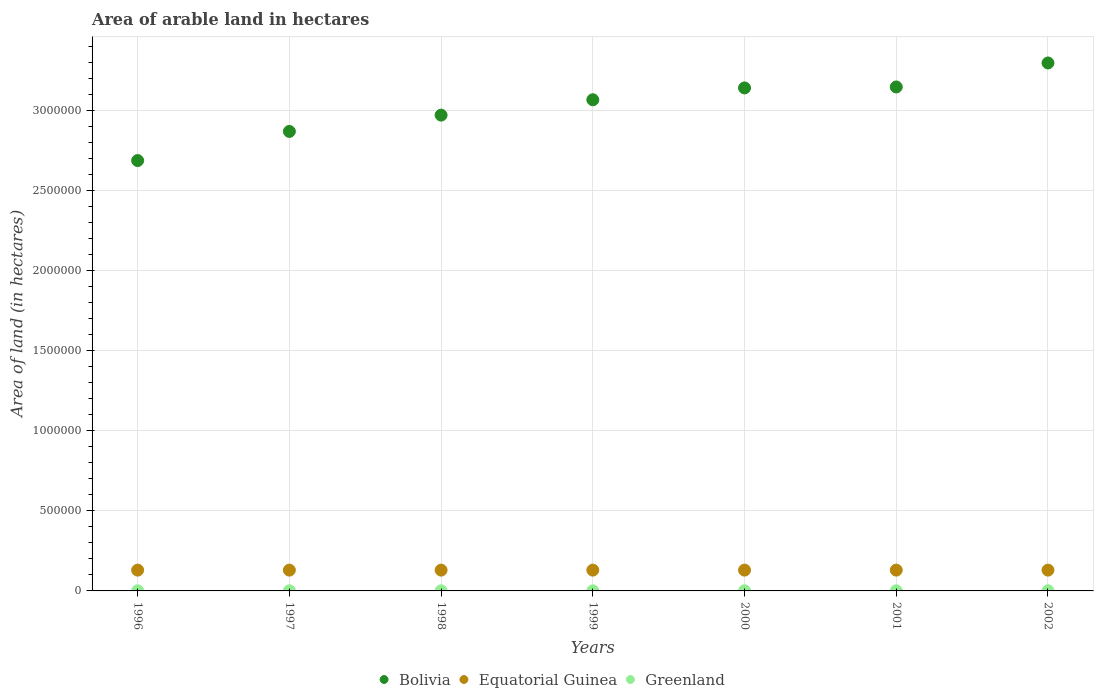How many different coloured dotlines are there?
Make the answer very short. 3. What is the total arable land in Greenland in 1997?
Your response must be concise. 700. Across all years, what is the maximum total arable land in Greenland?
Provide a succinct answer. 900. Across all years, what is the minimum total arable land in Greenland?
Offer a terse response. 700. In which year was the total arable land in Bolivia minimum?
Your answer should be very brief. 1996. What is the total total arable land in Greenland in the graph?
Make the answer very short. 5300. What is the difference between the total arable land in Bolivia in 1996 and that in 2000?
Give a very brief answer. -4.54e+05. What is the difference between the total arable land in Bolivia in 1998 and the total arable land in Greenland in 1996?
Provide a short and direct response. 2.97e+06. What is the average total arable land in Bolivia per year?
Your answer should be compact. 3.03e+06. In the year 2000, what is the difference between the total arable land in Equatorial Guinea and total arable land in Bolivia?
Provide a short and direct response. -3.01e+06. Is the sum of the total arable land in Equatorial Guinea in 1996 and 2000 greater than the maximum total arable land in Bolivia across all years?
Provide a short and direct response. No. Does the total arable land in Bolivia monotonically increase over the years?
Provide a succinct answer. Yes. How many years are there in the graph?
Offer a very short reply. 7. Are the values on the major ticks of Y-axis written in scientific E-notation?
Offer a terse response. No. Does the graph contain any zero values?
Make the answer very short. No. Where does the legend appear in the graph?
Give a very brief answer. Bottom center. What is the title of the graph?
Offer a very short reply. Area of arable land in hectares. What is the label or title of the Y-axis?
Offer a very short reply. Area of land (in hectares). What is the Area of land (in hectares) of Bolivia in 1996?
Provide a succinct answer. 2.69e+06. What is the Area of land (in hectares) in Equatorial Guinea in 1996?
Provide a succinct answer. 1.30e+05. What is the Area of land (in hectares) in Greenland in 1996?
Your answer should be compact. 700. What is the Area of land (in hectares) in Bolivia in 1997?
Your response must be concise. 2.87e+06. What is the Area of land (in hectares) of Greenland in 1997?
Keep it short and to the point. 700. What is the Area of land (in hectares) in Bolivia in 1998?
Your response must be concise. 2.97e+06. What is the Area of land (in hectares) in Greenland in 1998?
Your response must be concise. 700. What is the Area of land (in hectares) of Bolivia in 1999?
Offer a very short reply. 3.07e+06. What is the Area of land (in hectares) of Greenland in 1999?
Provide a succinct answer. 700. What is the Area of land (in hectares) of Bolivia in 2000?
Offer a very short reply. 3.14e+06. What is the Area of land (in hectares) of Equatorial Guinea in 2000?
Your response must be concise. 1.30e+05. What is the Area of land (in hectares) in Greenland in 2000?
Offer a very short reply. 800. What is the Area of land (in hectares) of Bolivia in 2001?
Provide a short and direct response. 3.15e+06. What is the Area of land (in hectares) in Equatorial Guinea in 2001?
Your response must be concise. 1.30e+05. What is the Area of land (in hectares) of Greenland in 2001?
Your answer should be very brief. 800. What is the Area of land (in hectares) of Bolivia in 2002?
Provide a succinct answer. 3.30e+06. What is the Area of land (in hectares) in Greenland in 2002?
Make the answer very short. 900. Across all years, what is the maximum Area of land (in hectares) of Bolivia?
Keep it short and to the point. 3.30e+06. Across all years, what is the maximum Area of land (in hectares) of Equatorial Guinea?
Your response must be concise. 1.30e+05. Across all years, what is the maximum Area of land (in hectares) of Greenland?
Your response must be concise. 900. Across all years, what is the minimum Area of land (in hectares) in Bolivia?
Provide a succinct answer. 2.69e+06. Across all years, what is the minimum Area of land (in hectares) of Equatorial Guinea?
Offer a very short reply. 1.30e+05. Across all years, what is the minimum Area of land (in hectares) in Greenland?
Your response must be concise. 700. What is the total Area of land (in hectares) of Bolivia in the graph?
Give a very brief answer. 2.12e+07. What is the total Area of land (in hectares) in Equatorial Guinea in the graph?
Give a very brief answer. 9.10e+05. What is the total Area of land (in hectares) of Greenland in the graph?
Give a very brief answer. 5300. What is the difference between the Area of land (in hectares) in Bolivia in 1996 and that in 1997?
Make the answer very short. -1.82e+05. What is the difference between the Area of land (in hectares) in Greenland in 1996 and that in 1997?
Ensure brevity in your answer.  0. What is the difference between the Area of land (in hectares) of Bolivia in 1996 and that in 1998?
Provide a short and direct response. -2.84e+05. What is the difference between the Area of land (in hectares) of Greenland in 1996 and that in 1998?
Keep it short and to the point. 0. What is the difference between the Area of land (in hectares) in Bolivia in 1996 and that in 1999?
Offer a terse response. -3.80e+05. What is the difference between the Area of land (in hectares) of Equatorial Guinea in 1996 and that in 1999?
Provide a succinct answer. 0. What is the difference between the Area of land (in hectares) in Bolivia in 1996 and that in 2000?
Give a very brief answer. -4.54e+05. What is the difference between the Area of land (in hectares) of Greenland in 1996 and that in 2000?
Your response must be concise. -100. What is the difference between the Area of land (in hectares) of Bolivia in 1996 and that in 2001?
Your answer should be compact. -4.60e+05. What is the difference between the Area of land (in hectares) of Equatorial Guinea in 1996 and that in 2001?
Your answer should be very brief. 0. What is the difference between the Area of land (in hectares) of Greenland in 1996 and that in 2001?
Your response must be concise. -100. What is the difference between the Area of land (in hectares) of Bolivia in 1996 and that in 2002?
Offer a terse response. -6.10e+05. What is the difference between the Area of land (in hectares) of Equatorial Guinea in 1996 and that in 2002?
Your answer should be compact. 0. What is the difference between the Area of land (in hectares) of Greenland in 1996 and that in 2002?
Provide a succinct answer. -200. What is the difference between the Area of land (in hectares) in Bolivia in 1997 and that in 1998?
Give a very brief answer. -1.02e+05. What is the difference between the Area of land (in hectares) of Bolivia in 1997 and that in 1999?
Offer a terse response. -1.98e+05. What is the difference between the Area of land (in hectares) in Bolivia in 1997 and that in 2000?
Provide a short and direct response. -2.72e+05. What is the difference between the Area of land (in hectares) in Greenland in 1997 and that in 2000?
Ensure brevity in your answer.  -100. What is the difference between the Area of land (in hectares) in Bolivia in 1997 and that in 2001?
Offer a very short reply. -2.78e+05. What is the difference between the Area of land (in hectares) of Greenland in 1997 and that in 2001?
Provide a short and direct response. -100. What is the difference between the Area of land (in hectares) of Bolivia in 1997 and that in 2002?
Provide a short and direct response. -4.28e+05. What is the difference between the Area of land (in hectares) in Greenland in 1997 and that in 2002?
Offer a very short reply. -200. What is the difference between the Area of land (in hectares) in Bolivia in 1998 and that in 1999?
Your answer should be very brief. -9.60e+04. What is the difference between the Area of land (in hectares) in Equatorial Guinea in 1998 and that in 1999?
Your answer should be compact. 0. What is the difference between the Area of land (in hectares) of Bolivia in 1998 and that in 2000?
Your answer should be very brief. -1.70e+05. What is the difference between the Area of land (in hectares) in Greenland in 1998 and that in 2000?
Provide a short and direct response. -100. What is the difference between the Area of land (in hectares) in Bolivia in 1998 and that in 2001?
Keep it short and to the point. -1.76e+05. What is the difference between the Area of land (in hectares) of Greenland in 1998 and that in 2001?
Offer a very short reply. -100. What is the difference between the Area of land (in hectares) in Bolivia in 1998 and that in 2002?
Give a very brief answer. -3.26e+05. What is the difference between the Area of land (in hectares) of Equatorial Guinea in 1998 and that in 2002?
Provide a short and direct response. 0. What is the difference between the Area of land (in hectares) in Greenland in 1998 and that in 2002?
Offer a terse response. -200. What is the difference between the Area of land (in hectares) in Bolivia in 1999 and that in 2000?
Keep it short and to the point. -7.40e+04. What is the difference between the Area of land (in hectares) of Greenland in 1999 and that in 2000?
Ensure brevity in your answer.  -100. What is the difference between the Area of land (in hectares) of Bolivia in 1999 and that in 2001?
Make the answer very short. -8.00e+04. What is the difference between the Area of land (in hectares) in Greenland in 1999 and that in 2001?
Provide a succinct answer. -100. What is the difference between the Area of land (in hectares) in Greenland in 1999 and that in 2002?
Give a very brief answer. -200. What is the difference between the Area of land (in hectares) in Bolivia in 2000 and that in 2001?
Make the answer very short. -6000. What is the difference between the Area of land (in hectares) of Greenland in 2000 and that in 2001?
Your answer should be very brief. 0. What is the difference between the Area of land (in hectares) in Bolivia in 2000 and that in 2002?
Provide a short and direct response. -1.56e+05. What is the difference between the Area of land (in hectares) in Greenland in 2000 and that in 2002?
Provide a succinct answer. -100. What is the difference between the Area of land (in hectares) of Bolivia in 2001 and that in 2002?
Make the answer very short. -1.50e+05. What is the difference between the Area of land (in hectares) in Greenland in 2001 and that in 2002?
Your response must be concise. -100. What is the difference between the Area of land (in hectares) in Bolivia in 1996 and the Area of land (in hectares) in Equatorial Guinea in 1997?
Offer a terse response. 2.56e+06. What is the difference between the Area of land (in hectares) in Bolivia in 1996 and the Area of land (in hectares) in Greenland in 1997?
Your answer should be very brief. 2.69e+06. What is the difference between the Area of land (in hectares) of Equatorial Guinea in 1996 and the Area of land (in hectares) of Greenland in 1997?
Give a very brief answer. 1.29e+05. What is the difference between the Area of land (in hectares) of Bolivia in 1996 and the Area of land (in hectares) of Equatorial Guinea in 1998?
Offer a terse response. 2.56e+06. What is the difference between the Area of land (in hectares) in Bolivia in 1996 and the Area of land (in hectares) in Greenland in 1998?
Your answer should be compact. 2.69e+06. What is the difference between the Area of land (in hectares) of Equatorial Guinea in 1996 and the Area of land (in hectares) of Greenland in 1998?
Offer a terse response. 1.29e+05. What is the difference between the Area of land (in hectares) in Bolivia in 1996 and the Area of land (in hectares) in Equatorial Guinea in 1999?
Keep it short and to the point. 2.56e+06. What is the difference between the Area of land (in hectares) of Bolivia in 1996 and the Area of land (in hectares) of Greenland in 1999?
Offer a very short reply. 2.69e+06. What is the difference between the Area of land (in hectares) of Equatorial Guinea in 1996 and the Area of land (in hectares) of Greenland in 1999?
Provide a short and direct response. 1.29e+05. What is the difference between the Area of land (in hectares) of Bolivia in 1996 and the Area of land (in hectares) of Equatorial Guinea in 2000?
Offer a terse response. 2.56e+06. What is the difference between the Area of land (in hectares) in Bolivia in 1996 and the Area of land (in hectares) in Greenland in 2000?
Keep it short and to the point. 2.69e+06. What is the difference between the Area of land (in hectares) in Equatorial Guinea in 1996 and the Area of land (in hectares) in Greenland in 2000?
Ensure brevity in your answer.  1.29e+05. What is the difference between the Area of land (in hectares) of Bolivia in 1996 and the Area of land (in hectares) of Equatorial Guinea in 2001?
Provide a succinct answer. 2.56e+06. What is the difference between the Area of land (in hectares) of Bolivia in 1996 and the Area of land (in hectares) of Greenland in 2001?
Provide a succinct answer. 2.69e+06. What is the difference between the Area of land (in hectares) of Equatorial Guinea in 1996 and the Area of land (in hectares) of Greenland in 2001?
Provide a short and direct response. 1.29e+05. What is the difference between the Area of land (in hectares) in Bolivia in 1996 and the Area of land (in hectares) in Equatorial Guinea in 2002?
Give a very brief answer. 2.56e+06. What is the difference between the Area of land (in hectares) in Bolivia in 1996 and the Area of land (in hectares) in Greenland in 2002?
Your answer should be compact. 2.69e+06. What is the difference between the Area of land (in hectares) in Equatorial Guinea in 1996 and the Area of land (in hectares) in Greenland in 2002?
Provide a succinct answer. 1.29e+05. What is the difference between the Area of land (in hectares) of Bolivia in 1997 and the Area of land (in hectares) of Equatorial Guinea in 1998?
Give a very brief answer. 2.74e+06. What is the difference between the Area of land (in hectares) of Bolivia in 1997 and the Area of land (in hectares) of Greenland in 1998?
Keep it short and to the point. 2.87e+06. What is the difference between the Area of land (in hectares) in Equatorial Guinea in 1997 and the Area of land (in hectares) in Greenland in 1998?
Your answer should be compact. 1.29e+05. What is the difference between the Area of land (in hectares) of Bolivia in 1997 and the Area of land (in hectares) of Equatorial Guinea in 1999?
Give a very brief answer. 2.74e+06. What is the difference between the Area of land (in hectares) in Bolivia in 1997 and the Area of land (in hectares) in Greenland in 1999?
Ensure brevity in your answer.  2.87e+06. What is the difference between the Area of land (in hectares) in Equatorial Guinea in 1997 and the Area of land (in hectares) in Greenland in 1999?
Offer a very short reply. 1.29e+05. What is the difference between the Area of land (in hectares) of Bolivia in 1997 and the Area of land (in hectares) of Equatorial Guinea in 2000?
Provide a succinct answer. 2.74e+06. What is the difference between the Area of land (in hectares) in Bolivia in 1997 and the Area of land (in hectares) in Greenland in 2000?
Your answer should be compact. 2.87e+06. What is the difference between the Area of land (in hectares) in Equatorial Guinea in 1997 and the Area of land (in hectares) in Greenland in 2000?
Your response must be concise. 1.29e+05. What is the difference between the Area of land (in hectares) of Bolivia in 1997 and the Area of land (in hectares) of Equatorial Guinea in 2001?
Make the answer very short. 2.74e+06. What is the difference between the Area of land (in hectares) of Bolivia in 1997 and the Area of land (in hectares) of Greenland in 2001?
Offer a very short reply. 2.87e+06. What is the difference between the Area of land (in hectares) in Equatorial Guinea in 1997 and the Area of land (in hectares) in Greenland in 2001?
Your answer should be compact. 1.29e+05. What is the difference between the Area of land (in hectares) of Bolivia in 1997 and the Area of land (in hectares) of Equatorial Guinea in 2002?
Provide a short and direct response. 2.74e+06. What is the difference between the Area of land (in hectares) in Bolivia in 1997 and the Area of land (in hectares) in Greenland in 2002?
Your response must be concise. 2.87e+06. What is the difference between the Area of land (in hectares) of Equatorial Guinea in 1997 and the Area of land (in hectares) of Greenland in 2002?
Offer a very short reply. 1.29e+05. What is the difference between the Area of land (in hectares) in Bolivia in 1998 and the Area of land (in hectares) in Equatorial Guinea in 1999?
Your answer should be very brief. 2.84e+06. What is the difference between the Area of land (in hectares) in Bolivia in 1998 and the Area of land (in hectares) in Greenland in 1999?
Keep it short and to the point. 2.97e+06. What is the difference between the Area of land (in hectares) of Equatorial Guinea in 1998 and the Area of land (in hectares) of Greenland in 1999?
Your answer should be compact. 1.29e+05. What is the difference between the Area of land (in hectares) in Bolivia in 1998 and the Area of land (in hectares) in Equatorial Guinea in 2000?
Offer a very short reply. 2.84e+06. What is the difference between the Area of land (in hectares) in Bolivia in 1998 and the Area of land (in hectares) in Greenland in 2000?
Offer a terse response. 2.97e+06. What is the difference between the Area of land (in hectares) in Equatorial Guinea in 1998 and the Area of land (in hectares) in Greenland in 2000?
Ensure brevity in your answer.  1.29e+05. What is the difference between the Area of land (in hectares) in Bolivia in 1998 and the Area of land (in hectares) in Equatorial Guinea in 2001?
Your response must be concise. 2.84e+06. What is the difference between the Area of land (in hectares) of Bolivia in 1998 and the Area of land (in hectares) of Greenland in 2001?
Your answer should be very brief. 2.97e+06. What is the difference between the Area of land (in hectares) of Equatorial Guinea in 1998 and the Area of land (in hectares) of Greenland in 2001?
Provide a short and direct response. 1.29e+05. What is the difference between the Area of land (in hectares) in Bolivia in 1998 and the Area of land (in hectares) in Equatorial Guinea in 2002?
Provide a short and direct response. 2.84e+06. What is the difference between the Area of land (in hectares) in Bolivia in 1998 and the Area of land (in hectares) in Greenland in 2002?
Provide a succinct answer. 2.97e+06. What is the difference between the Area of land (in hectares) in Equatorial Guinea in 1998 and the Area of land (in hectares) in Greenland in 2002?
Your answer should be very brief. 1.29e+05. What is the difference between the Area of land (in hectares) of Bolivia in 1999 and the Area of land (in hectares) of Equatorial Guinea in 2000?
Make the answer very short. 2.94e+06. What is the difference between the Area of land (in hectares) of Bolivia in 1999 and the Area of land (in hectares) of Greenland in 2000?
Your answer should be very brief. 3.07e+06. What is the difference between the Area of land (in hectares) in Equatorial Guinea in 1999 and the Area of land (in hectares) in Greenland in 2000?
Your answer should be compact. 1.29e+05. What is the difference between the Area of land (in hectares) in Bolivia in 1999 and the Area of land (in hectares) in Equatorial Guinea in 2001?
Make the answer very short. 2.94e+06. What is the difference between the Area of land (in hectares) of Bolivia in 1999 and the Area of land (in hectares) of Greenland in 2001?
Your answer should be compact. 3.07e+06. What is the difference between the Area of land (in hectares) of Equatorial Guinea in 1999 and the Area of land (in hectares) of Greenland in 2001?
Provide a short and direct response. 1.29e+05. What is the difference between the Area of land (in hectares) in Bolivia in 1999 and the Area of land (in hectares) in Equatorial Guinea in 2002?
Your answer should be very brief. 2.94e+06. What is the difference between the Area of land (in hectares) of Bolivia in 1999 and the Area of land (in hectares) of Greenland in 2002?
Ensure brevity in your answer.  3.07e+06. What is the difference between the Area of land (in hectares) of Equatorial Guinea in 1999 and the Area of land (in hectares) of Greenland in 2002?
Offer a terse response. 1.29e+05. What is the difference between the Area of land (in hectares) in Bolivia in 2000 and the Area of land (in hectares) in Equatorial Guinea in 2001?
Provide a short and direct response. 3.01e+06. What is the difference between the Area of land (in hectares) of Bolivia in 2000 and the Area of land (in hectares) of Greenland in 2001?
Give a very brief answer. 3.14e+06. What is the difference between the Area of land (in hectares) in Equatorial Guinea in 2000 and the Area of land (in hectares) in Greenland in 2001?
Offer a terse response. 1.29e+05. What is the difference between the Area of land (in hectares) in Bolivia in 2000 and the Area of land (in hectares) in Equatorial Guinea in 2002?
Your response must be concise. 3.01e+06. What is the difference between the Area of land (in hectares) in Bolivia in 2000 and the Area of land (in hectares) in Greenland in 2002?
Your answer should be very brief. 3.14e+06. What is the difference between the Area of land (in hectares) of Equatorial Guinea in 2000 and the Area of land (in hectares) of Greenland in 2002?
Your answer should be compact. 1.29e+05. What is the difference between the Area of land (in hectares) in Bolivia in 2001 and the Area of land (in hectares) in Equatorial Guinea in 2002?
Provide a short and direct response. 3.02e+06. What is the difference between the Area of land (in hectares) of Bolivia in 2001 and the Area of land (in hectares) of Greenland in 2002?
Offer a very short reply. 3.15e+06. What is the difference between the Area of land (in hectares) of Equatorial Guinea in 2001 and the Area of land (in hectares) of Greenland in 2002?
Offer a very short reply. 1.29e+05. What is the average Area of land (in hectares) in Bolivia per year?
Offer a very short reply. 3.03e+06. What is the average Area of land (in hectares) in Equatorial Guinea per year?
Offer a terse response. 1.30e+05. What is the average Area of land (in hectares) in Greenland per year?
Offer a terse response. 757.14. In the year 1996, what is the difference between the Area of land (in hectares) of Bolivia and Area of land (in hectares) of Equatorial Guinea?
Provide a short and direct response. 2.56e+06. In the year 1996, what is the difference between the Area of land (in hectares) of Bolivia and Area of land (in hectares) of Greenland?
Your answer should be very brief. 2.69e+06. In the year 1996, what is the difference between the Area of land (in hectares) in Equatorial Guinea and Area of land (in hectares) in Greenland?
Provide a short and direct response. 1.29e+05. In the year 1997, what is the difference between the Area of land (in hectares) of Bolivia and Area of land (in hectares) of Equatorial Guinea?
Your response must be concise. 2.74e+06. In the year 1997, what is the difference between the Area of land (in hectares) in Bolivia and Area of land (in hectares) in Greenland?
Give a very brief answer. 2.87e+06. In the year 1997, what is the difference between the Area of land (in hectares) of Equatorial Guinea and Area of land (in hectares) of Greenland?
Provide a succinct answer. 1.29e+05. In the year 1998, what is the difference between the Area of land (in hectares) in Bolivia and Area of land (in hectares) in Equatorial Guinea?
Give a very brief answer. 2.84e+06. In the year 1998, what is the difference between the Area of land (in hectares) of Bolivia and Area of land (in hectares) of Greenland?
Keep it short and to the point. 2.97e+06. In the year 1998, what is the difference between the Area of land (in hectares) in Equatorial Guinea and Area of land (in hectares) in Greenland?
Keep it short and to the point. 1.29e+05. In the year 1999, what is the difference between the Area of land (in hectares) in Bolivia and Area of land (in hectares) in Equatorial Guinea?
Keep it short and to the point. 2.94e+06. In the year 1999, what is the difference between the Area of land (in hectares) of Bolivia and Area of land (in hectares) of Greenland?
Offer a terse response. 3.07e+06. In the year 1999, what is the difference between the Area of land (in hectares) in Equatorial Guinea and Area of land (in hectares) in Greenland?
Offer a terse response. 1.29e+05. In the year 2000, what is the difference between the Area of land (in hectares) of Bolivia and Area of land (in hectares) of Equatorial Guinea?
Provide a succinct answer. 3.01e+06. In the year 2000, what is the difference between the Area of land (in hectares) in Bolivia and Area of land (in hectares) in Greenland?
Your answer should be compact. 3.14e+06. In the year 2000, what is the difference between the Area of land (in hectares) in Equatorial Guinea and Area of land (in hectares) in Greenland?
Provide a succinct answer. 1.29e+05. In the year 2001, what is the difference between the Area of land (in hectares) of Bolivia and Area of land (in hectares) of Equatorial Guinea?
Ensure brevity in your answer.  3.02e+06. In the year 2001, what is the difference between the Area of land (in hectares) in Bolivia and Area of land (in hectares) in Greenland?
Ensure brevity in your answer.  3.15e+06. In the year 2001, what is the difference between the Area of land (in hectares) in Equatorial Guinea and Area of land (in hectares) in Greenland?
Keep it short and to the point. 1.29e+05. In the year 2002, what is the difference between the Area of land (in hectares) in Bolivia and Area of land (in hectares) in Equatorial Guinea?
Keep it short and to the point. 3.17e+06. In the year 2002, what is the difference between the Area of land (in hectares) in Bolivia and Area of land (in hectares) in Greenland?
Ensure brevity in your answer.  3.30e+06. In the year 2002, what is the difference between the Area of land (in hectares) of Equatorial Guinea and Area of land (in hectares) of Greenland?
Provide a succinct answer. 1.29e+05. What is the ratio of the Area of land (in hectares) in Bolivia in 1996 to that in 1997?
Provide a short and direct response. 0.94. What is the ratio of the Area of land (in hectares) of Greenland in 1996 to that in 1997?
Keep it short and to the point. 1. What is the ratio of the Area of land (in hectares) of Bolivia in 1996 to that in 1998?
Give a very brief answer. 0.9. What is the ratio of the Area of land (in hectares) in Bolivia in 1996 to that in 1999?
Your answer should be very brief. 0.88. What is the ratio of the Area of land (in hectares) in Bolivia in 1996 to that in 2000?
Offer a terse response. 0.86. What is the ratio of the Area of land (in hectares) of Equatorial Guinea in 1996 to that in 2000?
Keep it short and to the point. 1. What is the ratio of the Area of land (in hectares) in Bolivia in 1996 to that in 2001?
Give a very brief answer. 0.85. What is the ratio of the Area of land (in hectares) in Bolivia in 1996 to that in 2002?
Your answer should be very brief. 0.82. What is the ratio of the Area of land (in hectares) in Bolivia in 1997 to that in 1998?
Provide a short and direct response. 0.97. What is the ratio of the Area of land (in hectares) of Bolivia in 1997 to that in 1999?
Offer a very short reply. 0.94. What is the ratio of the Area of land (in hectares) of Bolivia in 1997 to that in 2000?
Your answer should be compact. 0.91. What is the ratio of the Area of land (in hectares) of Bolivia in 1997 to that in 2001?
Your response must be concise. 0.91. What is the ratio of the Area of land (in hectares) in Equatorial Guinea in 1997 to that in 2001?
Offer a very short reply. 1. What is the ratio of the Area of land (in hectares) in Greenland in 1997 to that in 2001?
Make the answer very short. 0.88. What is the ratio of the Area of land (in hectares) in Bolivia in 1997 to that in 2002?
Provide a succinct answer. 0.87. What is the ratio of the Area of land (in hectares) of Equatorial Guinea in 1997 to that in 2002?
Offer a very short reply. 1. What is the ratio of the Area of land (in hectares) in Greenland in 1997 to that in 2002?
Ensure brevity in your answer.  0.78. What is the ratio of the Area of land (in hectares) of Bolivia in 1998 to that in 1999?
Your answer should be very brief. 0.97. What is the ratio of the Area of land (in hectares) in Equatorial Guinea in 1998 to that in 1999?
Provide a short and direct response. 1. What is the ratio of the Area of land (in hectares) of Bolivia in 1998 to that in 2000?
Your answer should be compact. 0.95. What is the ratio of the Area of land (in hectares) of Greenland in 1998 to that in 2000?
Offer a very short reply. 0.88. What is the ratio of the Area of land (in hectares) of Bolivia in 1998 to that in 2001?
Offer a very short reply. 0.94. What is the ratio of the Area of land (in hectares) in Greenland in 1998 to that in 2001?
Your response must be concise. 0.88. What is the ratio of the Area of land (in hectares) in Bolivia in 1998 to that in 2002?
Your answer should be compact. 0.9. What is the ratio of the Area of land (in hectares) in Equatorial Guinea in 1998 to that in 2002?
Keep it short and to the point. 1. What is the ratio of the Area of land (in hectares) in Bolivia in 1999 to that in 2000?
Offer a very short reply. 0.98. What is the ratio of the Area of land (in hectares) in Greenland in 1999 to that in 2000?
Your response must be concise. 0.88. What is the ratio of the Area of land (in hectares) of Bolivia in 1999 to that in 2001?
Give a very brief answer. 0.97. What is the ratio of the Area of land (in hectares) of Equatorial Guinea in 1999 to that in 2001?
Provide a short and direct response. 1. What is the ratio of the Area of land (in hectares) in Greenland in 1999 to that in 2001?
Ensure brevity in your answer.  0.88. What is the ratio of the Area of land (in hectares) of Bolivia in 1999 to that in 2002?
Provide a succinct answer. 0.93. What is the ratio of the Area of land (in hectares) of Equatorial Guinea in 1999 to that in 2002?
Keep it short and to the point. 1. What is the ratio of the Area of land (in hectares) of Greenland in 1999 to that in 2002?
Offer a very short reply. 0.78. What is the ratio of the Area of land (in hectares) in Equatorial Guinea in 2000 to that in 2001?
Your answer should be very brief. 1. What is the ratio of the Area of land (in hectares) in Greenland in 2000 to that in 2001?
Give a very brief answer. 1. What is the ratio of the Area of land (in hectares) in Bolivia in 2000 to that in 2002?
Your answer should be very brief. 0.95. What is the ratio of the Area of land (in hectares) in Greenland in 2000 to that in 2002?
Offer a very short reply. 0.89. What is the ratio of the Area of land (in hectares) in Bolivia in 2001 to that in 2002?
Offer a terse response. 0.95. What is the ratio of the Area of land (in hectares) in Equatorial Guinea in 2001 to that in 2002?
Keep it short and to the point. 1. What is the ratio of the Area of land (in hectares) in Greenland in 2001 to that in 2002?
Your answer should be very brief. 0.89. What is the difference between the highest and the second highest Area of land (in hectares) of Bolivia?
Your response must be concise. 1.50e+05. What is the difference between the highest and the second highest Area of land (in hectares) of Equatorial Guinea?
Make the answer very short. 0. What is the difference between the highest and the second highest Area of land (in hectares) in Greenland?
Offer a terse response. 100. 